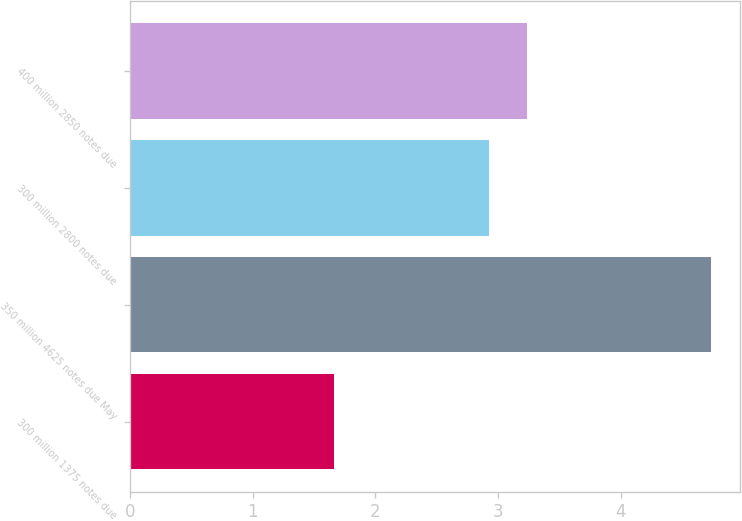Convert chart. <chart><loc_0><loc_0><loc_500><loc_500><bar_chart><fcel>300 million 1375 notes due<fcel>350 million 4625 notes due May<fcel>300 million 2800 notes due<fcel>400 million 2850 notes due<nl><fcel>1.66<fcel>4.74<fcel>2.93<fcel>3.24<nl></chart> 